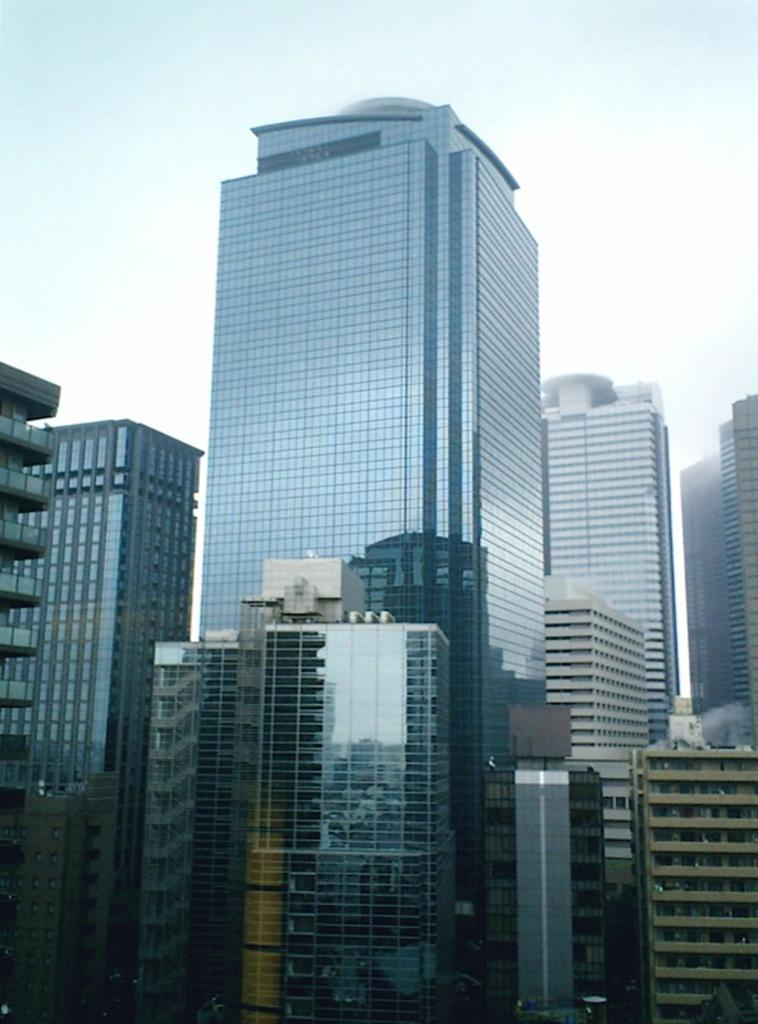What type of structures are present in the image? There are buildings in the image. What features can be observed on the buildings? The buildings have windows and glass elements. What is visible at the top of the image? The sky is visible at the top of the image. How many bananas are hanging from the windows of the buildings in the image? There are no bananas present in the image; the buildings have windows and glass elements. 